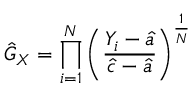<formula> <loc_0><loc_0><loc_500><loc_500>{ \hat { G } } _ { X } = \prod _ { i = 1 } ^ { N } \left ( { \frac { Y _ { i } - { \hat { a } } } { { \hat { c } } - { \hat { a } } } } \right ) ^ { \frac { 1 } { N } }</formula> 